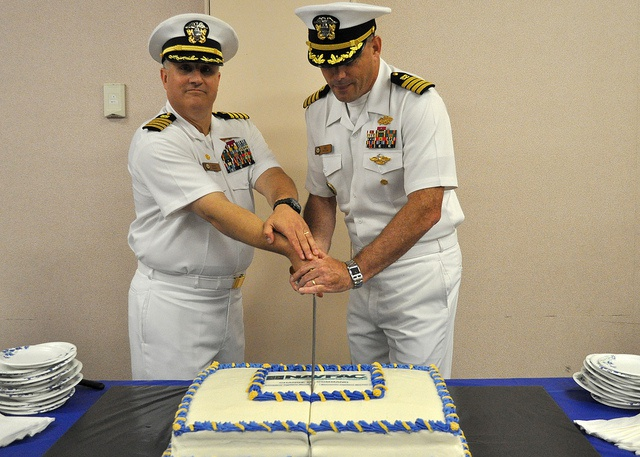Describe the objects in this image and their specific colors. I can see dining table in darkgray, beige, gray, and black tones, people in darkgray, lightgray, and gray tones, people in darkgray, lightgray, and gray tones, cake in darkgray, beige, lightyellow, and blue tones, and knife in darkgray and gray tones in this image. 